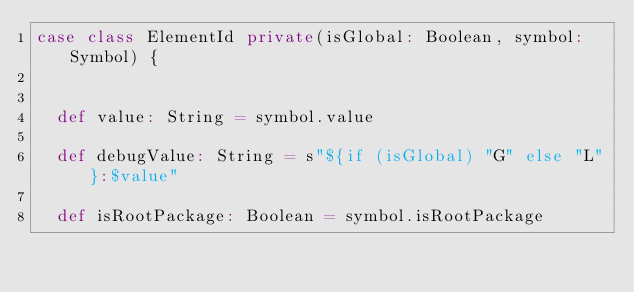Convert code to text. <code><loc_0><loc_0><loc_500><loc_500><_Scala_>case class ElementId private(isGlobal: Boolean, symbol: Symbol) {


  def value: String = symbol.value

  def debugValue: String = s"${if (isGlobal) "G" else "L"}:$value"

  def isRootPackage: Boolean = symbol.isRootPackage
</code> 